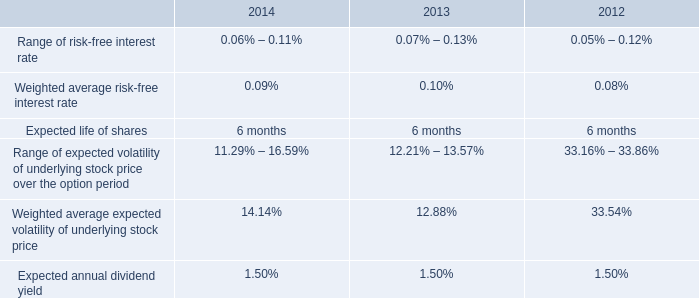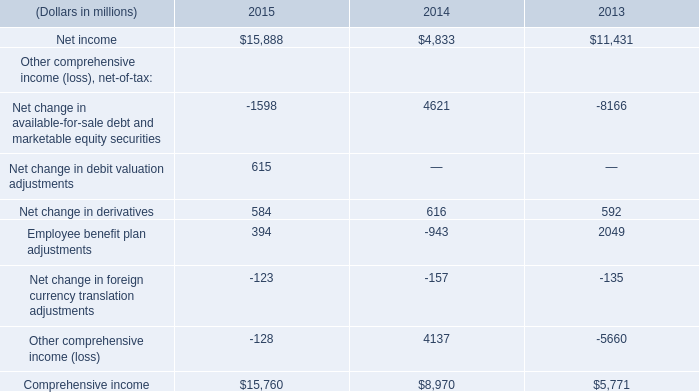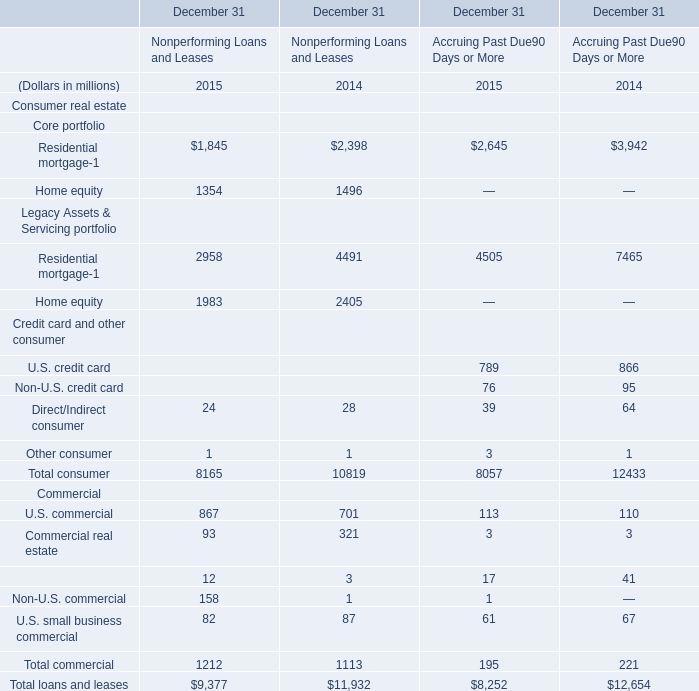what is the growth rate in the weighted average fair value per share of espp share purchase options from 2012 to 2013? 
Computations: ((13.42 - 13.64) / 13.64)
Answer: -0.01613. assuming conversion at the maximum share conversion rate , how many common shares would result from a conversion of the mandatory convertible preferred stock , series a? 
Computations: (6000000 * 1.1468)
Answer: 6880800.0. 